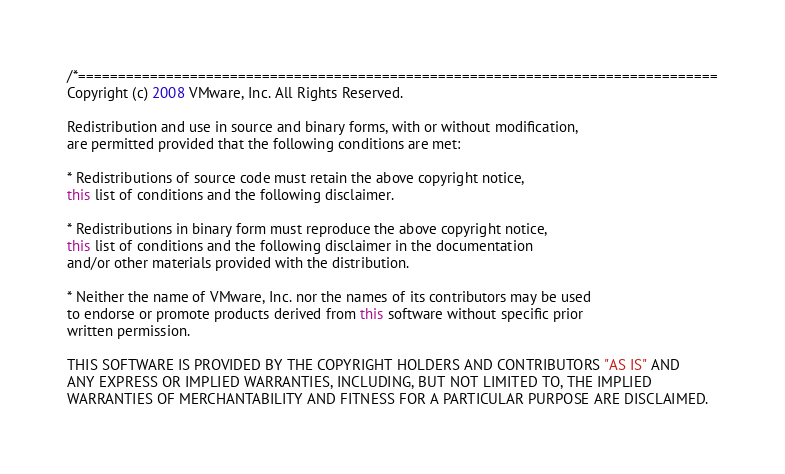<code> <loc_0><loc_0><loc_500><loc_500><_Java_>/*================================================================================
Copyright (c) 2008 VMware, Inc. All Rights Reserved.

Redistribution and use in source and binary forms, with or without modification,
are permitted provided that the following conditions are met:

* Redistributions of source code must retain the above copyright notice,
this list of conditions and the following disclaimer.

* Redistributions in binary form must reproduce the above copyright notice,
this list of conditions and the following disclaimer in the documentation
and/or other materials provided with the distribution.

* Neither the name of VMware, Inc. nor the names of its contributors may be used
to endorse or promote products derived from this software without specific prior
written permission.

THIS SOFTWARE IS PROVIDED BY THE COPYRIGHT HOLDERS AND CONTRIBUTORS "AS IS" AND
ANY EXPRESS OR IMPLIED WARRANTIES, INCLUDING, BUT NOT LIMITED TO, THE IMPLIED
WARRANTIES OF MERCHANTABILITY AND FITNESS FOR A PARTICULAR PURPOSE ARE DISCLAIMED.</code> 